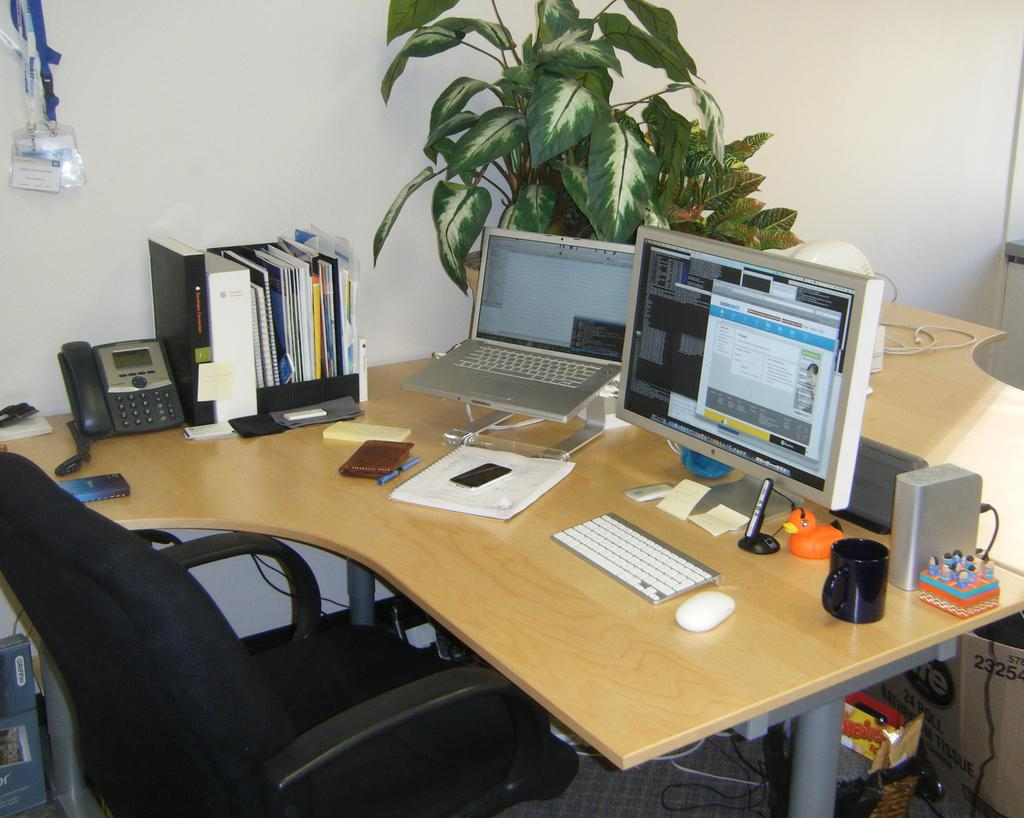What type of furniture is present in the image? There is a chair in the image. What surface is visible for working or using a computer? There is a desktop in the image. What electronic device is present in the image? There is a laptop in the image. What type of documents or papers can be seen in the image? There are files in the image. What communication device is present in the image? There is a telephone in the image. What type of living organism is present in the image? There is a plant on a table in the image. What can be seen in the background of the image? There is a wall and a box in the background of the image. How many women are skating under the arch in the image? There are no women, skating, or arches present in the image. 